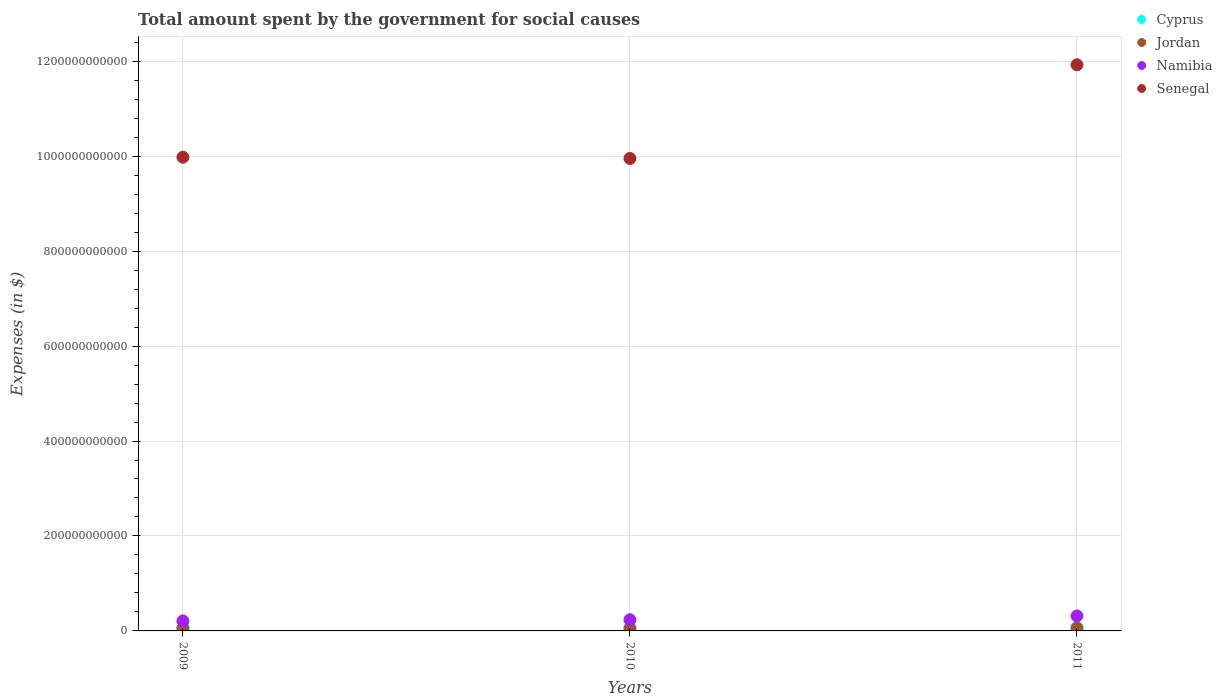How many different coloured dotlines are there?
Your response must be concise. 4. Is the number of dotlines equal to the number of legend labels?
Provide a short and direct response. Yes. What is the amount spent for social causes by the government in Senegal in 2010?
Offer a very short reply. 9.95e+11. Across all years, what is the maximum amount spent for social causes by the government in Cyprus?
Your response must be concise. 7.69e+09. Across all years, what is the minimum amount spent for social causes by the government in Namibia?
Your answer should be compact. 2.09e+1. In which year was the amount spent for social causes by the government in Senegal maximum?
Your answer should be very brief. 2011. In which year was the amount spent for social causes by the government in Cyprus minimum?
Give a very brief answer. 2009. What is the total amount spent for social causes by the government in Namibia in the graph?
Ensure brevity in your answer.  7.61e+1. What is the difference between the amount spent for social causes by the government in Senegal in 2009 and that in 2010?
Ensure brevity in your answer.  2.67e+09. What is the difference between the amount spent for social causes by the government in Senegal in 2010 and the amount spent for social causes by the government in Jordan in 2009?
Your answer should be compact. 9.90e+11. What is the average amount spent for social causes by the government in Jordan per year?
Provide a short and direct response. 5.19e+09. In the year 2010, what is the difference between the amount spent for social causes by the government in Jordan and amount spent for social causes by the government in Cyprus?
Offer a very short reply. -2.66e+09. In how many years, is the amount spent for social causes by the government in Jordan greater than 280000000000 $?
Your answer should be very brief. 0. What is the ratio of the amount spent for social causes by the government in Namibia in 2009 to that in 2010?
Your response must be concise. 0.89. What is the difference between the highest and the second highest amount spent for social causes by the government in Namibia?
Make the answer very short. 7.94e+09. What is the difference between the highest and the lowest amount spent for social causes by the government in Jordan?
Offer a very short reply. 9.93e+08. In how many years, is the amount spent for social causes by the government in Namibia greater than the average amount spent for social causes by the government in Namibia taken over all years?
Provide a short and direct response. 1. Is the sum of the amount spent for social causes by the government in Jordan in 2009 and 2011 greater than the maximum amount spent for social causes by the government in Cyprus across all years?
Make the answer very short. Yes. Does the amount spent for social causes by the government in Namibia monotonically increase over the years?
Your answer should be compact. Yes. Is the amount spent for social causes by the government in Senegal strictly less than the amount spent for social causes by the government in Namibia over the years?
Offer a terse response. No. What is the difference between two consecutive major ticks on the Y-axis?
Offer a very short reply. 2.00e+11. Does the graph contain grids?
Give a very brief answer. Yes. What is the title of the graph?
Keep it short and to the point. Total amount spent by the government for social causes. What is the label or title of the X-axis?
Your answer should be compact. Years. What is the label or title of the Y-axis?
Make the answer very short. Expenses (in $). What is the Expenses (in $) of Cyprus in 2009?
Your answer should be compact. 7.11e+09. What is the Expenses (in $) of Jordan in 2009?
Keep it short and to the point. 5.09e+09. What is the Expenses (in $) in Namibia in 2009?
Offer a terse response. 2.09e+1. What is the Expenses (in $) in Senegal in 2009?
Offer a terse response. 9.98e+11. What is the Expenses (in $) of Cyprus in 2010?
Give a very brief answer. 7.41e+09. What is the Expenses (in $) in Jordan in 2010?
Your answer should be compact. 4.75e+09. What is the Expenses (in $) in Namibia in 2010?
Your response must be concise. 2.36e+1. What is the Expenses (in $) of Senegal in 2010?
Offer a terse response. 9.95e+11. What is the Expenses (in $) in Cyprus in 2011?
Offer a very short reply. 7.69e+09. What is the Expenses (in $) in Jordan in 2011?
Offer a very short reply. 5.74e+09. What is the Expenses (in $) in Namibia in 2011?
Give a very brief answer. 3.16e+1. What is the Expenses (in $) of Senegal in 2011?
Give a very brief answer. 1.19e+12. Across all years, what is the maximum Expenses (in $) of Cyprus?
Your answer should be very brief. 7.69e+09. Across all years, what is the maximum Expenses (in $) in Jordan?
Your answer should be compact. 5.74e+09. Across all years, what is the maximum Expenses (in $) of Namibia?
Offer a very short reply. 3.16e+1. Across all years, what is the maximum Expenses (in $) in Senegal?
Your answer should be compact. 1.19e+12. Across all years, what is the minimum Expenses (in $) in Cyprus?
Ensure brevity in your answer.  7.11e+09. Across all years, what is the minimum Expenses (in $) of Jordan?
Offer a very short reply. 4.75e+09. Across all years, what is the minimum Expenses (in $) in Namibia?
Offer a terse response. 2.09e+1. Across all years, what is the minimum Expenses (in $) in Senegal?
Provide a short and direct response. 9.95e+11. What is the total Expenses (in $) of Cyprus in the graph?
Provide a short and direct response. 2.22e+1. What is the total Expenses (in $) in Jordan in the graph?
Ensure brevity in your answer.  1.56e+1. What is the total Expenses (in $) of Namibia in the graph?
Your answer should be compact. 7.61e+1. What is the total Expenses (in $) of Senegal in the graph?
Make the answer very short. 3.19e+12. What is the difference between the Expenses (in $) in Cyprus in 2009 and that in 2010?
Offer a very short reply. -3.04e+08. What is the difference between the Expenses (in $) of Jordan in 2009 and that in 2010?
Give a very brief answer. 3.43e+08. What is the difference between the Expenses (in $) in Namibia in 2009 and that in 2010?
Offer a terse response. -2.68e+09. What is the difference between the Expenses (in $) in Senegal in 2009 and that in 2010?
Your response must be concise. 2.67e+09. What is the difference between the Expenses (in $) in Cyprus in 2009 and that in 2011?
Ensure brevity in your answer.  -5.85e+08. What is the difference between the Expenses (in $) of Jordan in 2009 and that in 2011?
Provide a short and direct response. -6.50e+08. What is the difference between the Expenses (in $) in Namibia in 2009 and that in 2011?
Give a very brief answer. -1.06e+1. What is the difference between the Expenses (in $) in Senegal in 2009 and that in 2011?
Give a very brief answer. -1.95e+11. What is the difference between the Expenses (in $) in Cyprus in 2010 and that in 2011?
Your answer should be compact. -2.81e+08. What is the difference between the Expenses (in $) in Jordan in 2010 and that in 2011?
Make the answer very short. -9.93e+08. What is the difference between the Expenses (in $) of Namibia in 2010 and that in 2011?
Ensure brevity in your answer.  -7.94e+09. What is the difference between the Expenses (in $) of Senegal in 2010 and that in 2011?
Provide a short and direct response. -1.97e+11. What is the difference between the Expenses (in $) of Cyprus in 2009 and the Expenses (in $) of Jordan in 2010?
Your answer should be compact. 2.36e+09. What is the difference between the Expenses (in $) in Cyprus in 2009 and the Expenses (in $) in Namibia in 2010?
Offer a terse response. -1.65e+1. What is the difference between the Expenses (in $) in Cyprus in 2009 and the Expenses (in $) in Senegal in 2010?
Keep it short and to the point. -9.88e+11. What is the difference between the Expenses (in $) of Jordan in 2009 and the Expenses (in $) of Namibia in 2010?
Your answer should be very brief. -1.85e+1. What is the difference between the Expenses (in $) of Jordan in 2009 and the Expenses (in $) of Senegal in 2010?
Make the answer very short. -9.90e+11. What is the difference between the Expenses (in $) of Namibia in 2009 and the Expenses (in $) of Senegal in 2010?
Keep it short and to the point. -9.74e+11. What is the difference between the Expenses (in $) of Cyprus in 2009 and the Expenses (in $) of Jordan in 2011?
Ensure brevity in your answer.  1.37e+09. What is the difference between the Expenses (in $) in Cyprus in 2009 and the Expenses (in $) in Namibia in 2011?
Your answer should be compact. -2.44e+1. What is the difference between the Expenses (in $) of Cyprus in 2009 and the Expenses (in $) of Senegal in 2011?
Your response must be concise. -1.19e+12. What is the difference between the Expenses (in $) of Jordan in 2009 and the Expenses (in $) of Namibia in 2011?
Provide a short and direct response. -2.65e+1. What is the difference between the Expenses (in $) in Jordan in 2009 and the Expenses (in $) in Senegal in 2011?
Ensure brevity in your answer.  -1.19e+12. What is the difference between the Expenses (in $) in Namibia in 2009 and the Expenses (in $) in Senegal in 2011?
Offer a terse response. -1.17e+12. What is the difference between the Expenses (in $) of Cyprus in 2010 and the Expenses (in $) of Jordan in 2011?
Your answer should be very brief. 1.67e+09. What is the difference between the Expenses (in $) of Cyprus in 2010 and the Expenses (in $) of Namibia in 2011?
Give a very brief answer. -2.41e+1. What is the difference between the Expenses (in $) of Cyprus in 2010 and the Expenses (in $) of Senegal in 2011?
Ensure brevity in your answer.  -1.19e+12. What is the difference between the Expenses (in $) in Jordan in 2010 and the Expenses (in $) in Namibia in 2011?
Give a very brief answer. -2.68e+1. What is the difference between the Expenses (in $) of Jordan in 2010 and the Expenses (in $) of Senegal in 2011?
Ensure brevity in your answer.  -1.19e+12. What is the difference between the Expenses (in $) in Namibia in 2010 and the Expenses (in $) in Senegal in 2011?
Offer a very short reply. -1.17e+12. What is the average Expenses (in $) of Cyprus per year?
Offer a terse response. 7.40e+09. What is the average Expenses (in $) of Jordan per year?
Provide a short and direct response. 5.19e+09. What is the average Expenses (in $) in Namibia per year?
Ensure brevity in your answer.  2.54e+1. What is the average Expenses (in $) in Senegal per year?
Give a very brief answer. 1.06e+12. In the year 2009, what is the difference between the Expenses (in $) in Cyprus and Expenses (in $) in Jordan?
Ensure brevity in your answer.  2.02e+09. In the year 2009, what is the difference between the Expenses (in $) of Cyprus and Expenses (in $) of Namibia?
Offer a very short reply. -1.38e+1. In the year 2009, what is the difference between the Expenses (in $) in Cyprus and Expenses (in $) in Senegal?
Provide a short and direct response. -9.91e+11. In the year 2009, what is the difference between the Expenses (in $) of Jordan and Expenses (in $) of Namibia?
Your answer should be compact. -1.58e+1. In the year 2009, what is the difference between the Expenses (in $) of Jordan and Expenses (in $) of Senegal?
Give a very brief answer. -9.93e+11. In the year 2009, what is the difference between the Expenses (in $) of Namibia and Expenses (in $) of Senegal?
Your answer should be compact. -9.77e+11. In the year 2010, what is the difference between the Expenses (in $) in Cyprus and Expenses (in $) in Jordan?
Keep it short and to the point. 2.66e+09. In the year 2010, what is the difference between the Expenses (in $) in Cyprus and Expenses (in $) in Namibia?
Offer a very short reply. -1.62e+1. In the year 2010, what is the difference between the Expenses (in $) in Cyprus and Expenses (in $) in Senegal?
Ensure brevity in your answer.  -9.88e+11. In the year 2010, what is the difference between the Expenses (in $) of Jordan and Expenses (in $) of Namibia?
Your answer should be very brief. -1.89e+1. In the year 2010, what is the difference between the Expenses (in $) in Jordan and Expenses (in $) in Senegal?
Give a very brief answer. -9.90e+11. In the year 2010, what is the difference between the Expenses (in $) of Namibia and Expenses (in $) of Senegal?
Provide a succinct answer. -9.72e+11. In the year 2011, what is the difference between the Expenses (in $) of Cyprus and Expenses (in $) of Jordan?
Make the answer very short. 1.95e+09. In the year 2011, what is the difference between the Expenses (in $) of Cyprus and Expenses (in $) of Namibia?
Give a very brief answer. -2.39e+1. In the year 2011, what is the difference between the Expenses (in $) of Cyprus and Expenses (in $) of Senegal?
Ensure brevity in your answer.  -1.18e+12. In the year 2011, what is the difference between the Expenses (in $) in Jordan and Expenses (in $) in Namibia?
Keep it short and to the point. -2.58e+1. In the year 2011, what is the difference between the Expenses (in $) in Jordan and Expenses (in $) in Senegal?
Offer a very short reply. -1.19e+12. In the year 2011, what is the difference between the Expenses (in $) in Namibia and Expenses (in $) in Senegal?
Offer a very short reply. -1.16e+12. What is the ratio of the Expenses (in $) of Jordan in 2009 to that in 2010?
Your answer should be very brief. 1.07. What is the ratio of the Expenses (in $) in Namibia in 2009 to that in 2010?
Provide a short and direct response. 0.89. What is the ratio of the Expenses (in $) of Senegal in 2009 to that in 2010?
Offer a terse response. 1. What is the ratio of the Expenses (in $) of Cyprus in 2009 to that in 2011?
Your response must be concise. 0.92. What is the ratio of the Expenses (in $) in Jordan in 2009 to that in 2011?
Your answer should be compact. 0.89. What is the ratio of the Expenses (in $) of Namibia in 2009 to that in 2011?
Offer a very short reply. 0.66. What is the ratio of the Expenses (in $) of Senegal in 2009 to that in 2011?
Your answer should be compact. 0.84. What is the ratio of the Expenses (in $) of Cyprus in 2010 to that in 2011?
Offer a very short reply. 0.96. What is the ratio of the Expenses (in $) of Jordan in 2010 to that in 2011?
Keep it short and to the point. 0.83. What is the ratio of the Expenses (in $) of Namibia in 2010 to that in 2011?
Your response must be concise. 0.75. What is the ratio of the Expenses (in $) of Senegal in 2010 to that in 2011?
Give a very brief answer. 0.83. What is the difference between the highest and the second highest Expenses (in $) in Cyprus?
Offer a very short reply. 2.81e+08. What is the difference between the highest and the second highest Expenses (in $) in Jordan?
Provide a succinct answer. 6.50e+08. What is the difference between the highest and the second highest Expenses (in $) of Namibia?
Your answer should be compact. 7.94e+09. What is the difference between the highest and the second highest Expenses (in $) in Senegal?
Provide a short and direct response. 1.95e+11. What is the difference between the highest and the lowest Expenses (in $) of Cyprus?
Provide a short and direct response. 5.85e+08. What is the difference between the highest and the lowest Expenses (in $) in Jordan?
Your answer should be compact. 9.93e+08. What is the difference between the highest and the lowest Expenses (in $) of Namibia?
Give a very brief answer. 1.06e+1. What is the difference between the highest and the lowest Expenses (in $) in Senegal?
Offer a very short reply. 1.97e+11. 